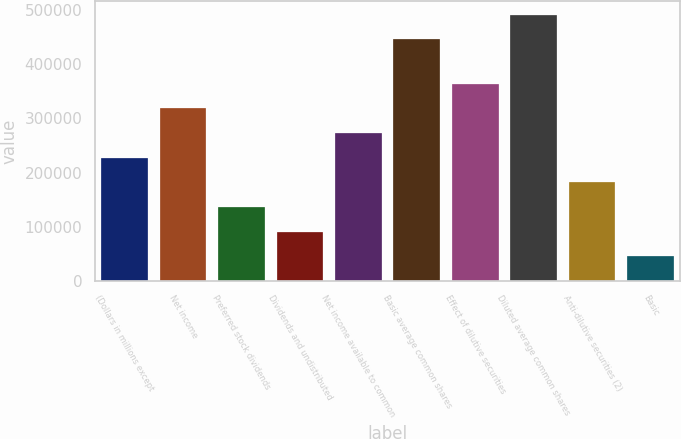Convert chart to OTSL. <chart><loc_0><loc_0><loc_500><loc_500><bar_chart><fcel>(Dollars in millions except<fcel>Net income<fcel>Preferred stock dividends<fcel>Dividends and undistributed<fcel>Net income available to common<fcel>Basic average common shares<fcel>Effect of dilutive securities<fcel>Diluted average common shares<fcel>Anti-dilutive securities (2)<fcel>Basic<nl><fcel>227580<fcel>318610<fcel>136550<fcel>91034.7<fcel>273095<fcel>446245<fcel>364125<fcel>491760<fcel>182065<fcel>45519.7<nl></chart> 